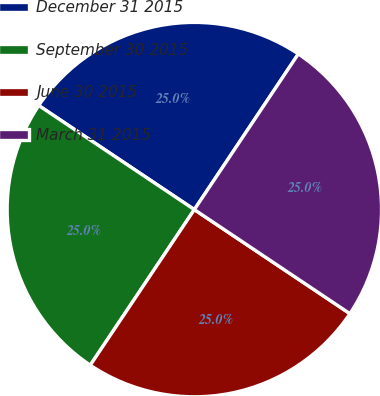Convert chart to OTSL. <chart><loc_0><loc_0><loc_500><loc_500><pie_chart><fcel>December 31 2015<fcel>September 30 2015<fcel>June 30 2015<fcel>March 31 2015<nl><fcel>24.99%<fcel>25.0%<fcel>25.0%<fcel>25.01%<nl></chart> 